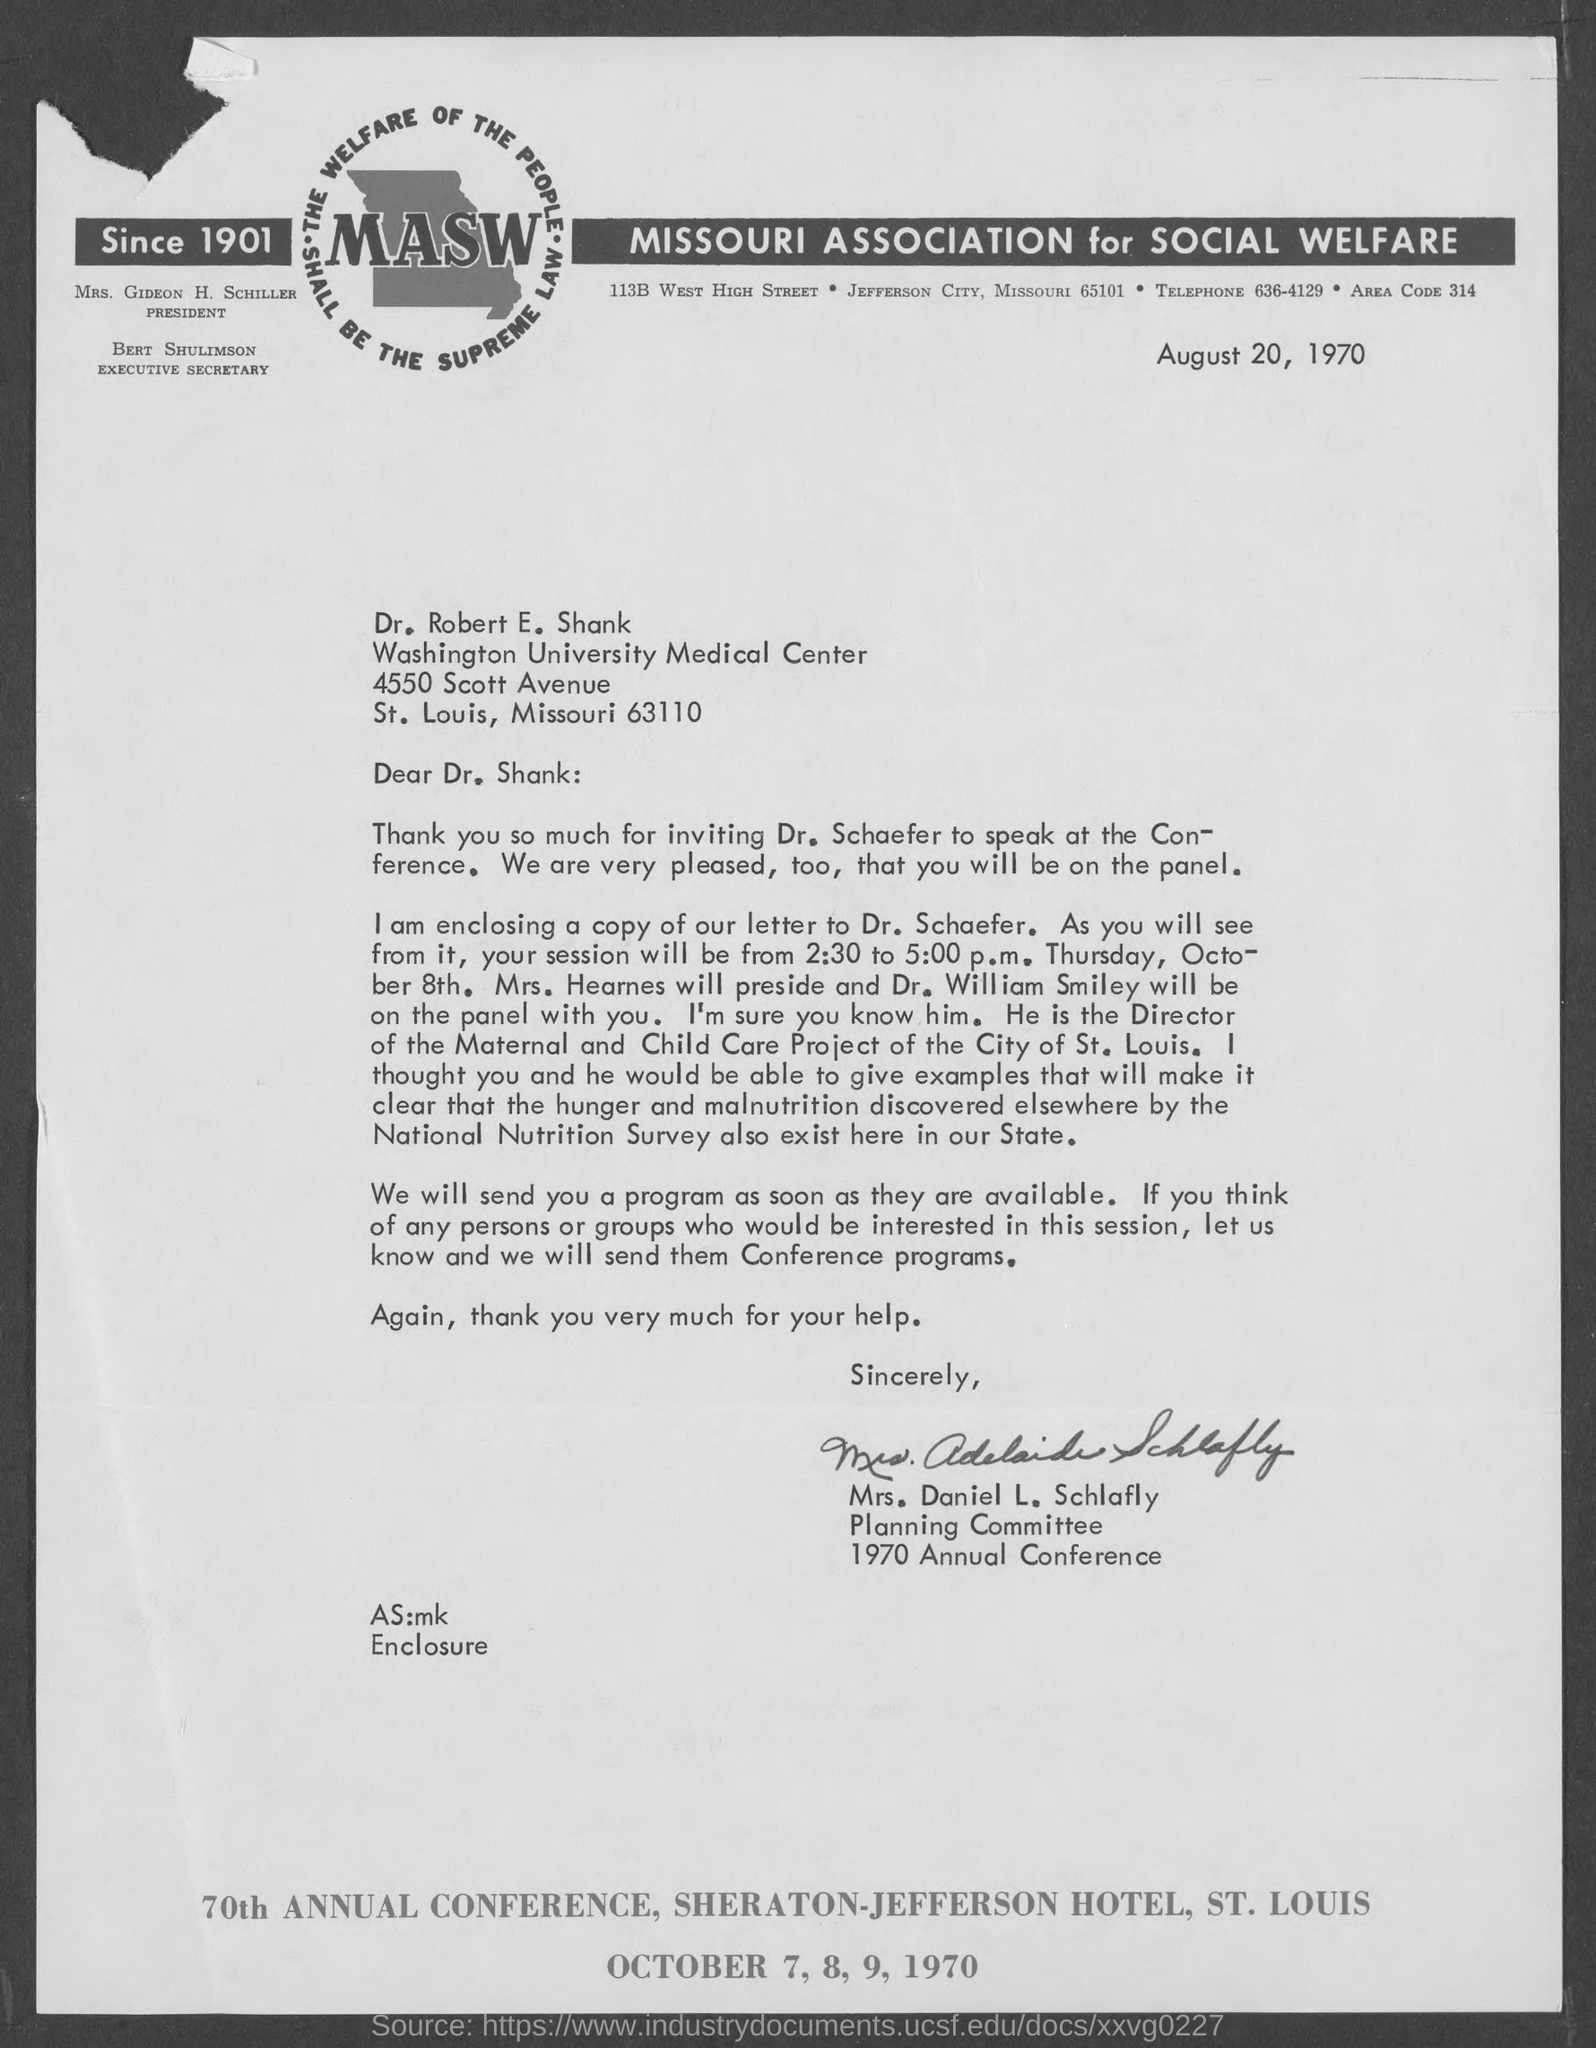Draw attention to some important aspects in this diagram. The conference will be held on October 7, 8, 9, 1970. The sender is Mrs. Daniel L. Schlafly. The document is dated August 20, 1970. The location of the annual conference will be held at the Sheraton-Jefferson Hotel in St. Louis. It has been announced that Dr. Schaefer has been invited to speak at the Conference. 